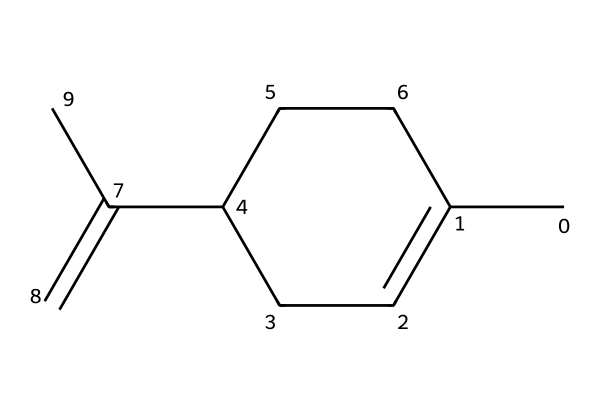What is the molecular formula of limonene? To determine the molecular formula, we count the number of carbon (C), hydrogen (H), and any other atoms present. From the SMILES notation, there are 10 carbon atoms and 16 hydrogen atoms, resulting in the molecular formula C10H16.
Answer: C10H16 How many rings are present in limonene? By analyzing the structure represented in the SMILES, limonene has no cyclic (ring) structures evident in its linear arrangement, indicating it is acyclic.
Answer: 0 What is the structural feature that categorizes limonene as an aliphatic compound? The primary characteristic of aliphatic compounds is that they consist of carbon and hydrogen atoms arranged in straight or branched chains without any aromatic rings. Since limonene has a structure showing only carbon and hydrogen without aromaticity, it is classified as aliphatic.
Answer: non-aromatic Which functional groups can be identified in limonene? Although limonene is primarily hydrocarbon, it features a double bond in its structure. This means it has an alkene functional group. Identifying functional groups helps distinguish its chemical behavior; in this case, it classifies as an alkene.
Answer: alkene How many double bonds are present in limonene? In limonene’s structure, the presence of one double bond can be confirmed by examining the C=C bonds in the chemical representation. Thus, counting leads to the conclusion that there is one double bond.
Answer: 1 What type of aliphatic compound is limonene? Limonene is classified as a terpene because it consists of multiple isoprene units and is derived from plants, specifically citrus fruits. This classification helps in understanding its natural origin and applications.
Answer: terpene 